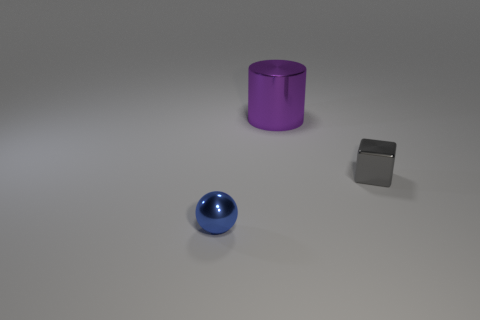Are there any other things that are the same size as the gray cube?
Offer a terse response. Yes. There is a tiny metal object on the right side of the small blue sphere; does it have the same shape as the small blue object?
Keep it short and to the point. No. How many metal things are both in front of the big cylinder and on the left side of the small cube?
Make the answer very short. 1. What is the color of the metal object that is on the right side of the purple metallic thing behind the tiny object behind the blue object?
Offer a very short reply. Gray. There is a tiny shiny object behind the blue ball; how many metallic balls are behind it?
Your answer should be compact. 0. What number of other things are there of the same shape as the gray metallic thing?
Offer a very short reply. 0. How many things are large things or objects that are left of the tiny gray metal cube?
Offer a very short reply. 2. Are there more tiny gray things to the left of the cylinder than gray metal cubes that are to the left of the blue ball?
Give a very brief answer. No. The small shiny thing behind the tiny thing that is in front of the tiny object to the right of the small blue thing is what shape?
Ensure brevity in your answer.  Cube. There is a thing behind the tiny thing that is to the right of the purple metallic object; what is its shape?
Keep it short and to the point. Cylinder. 